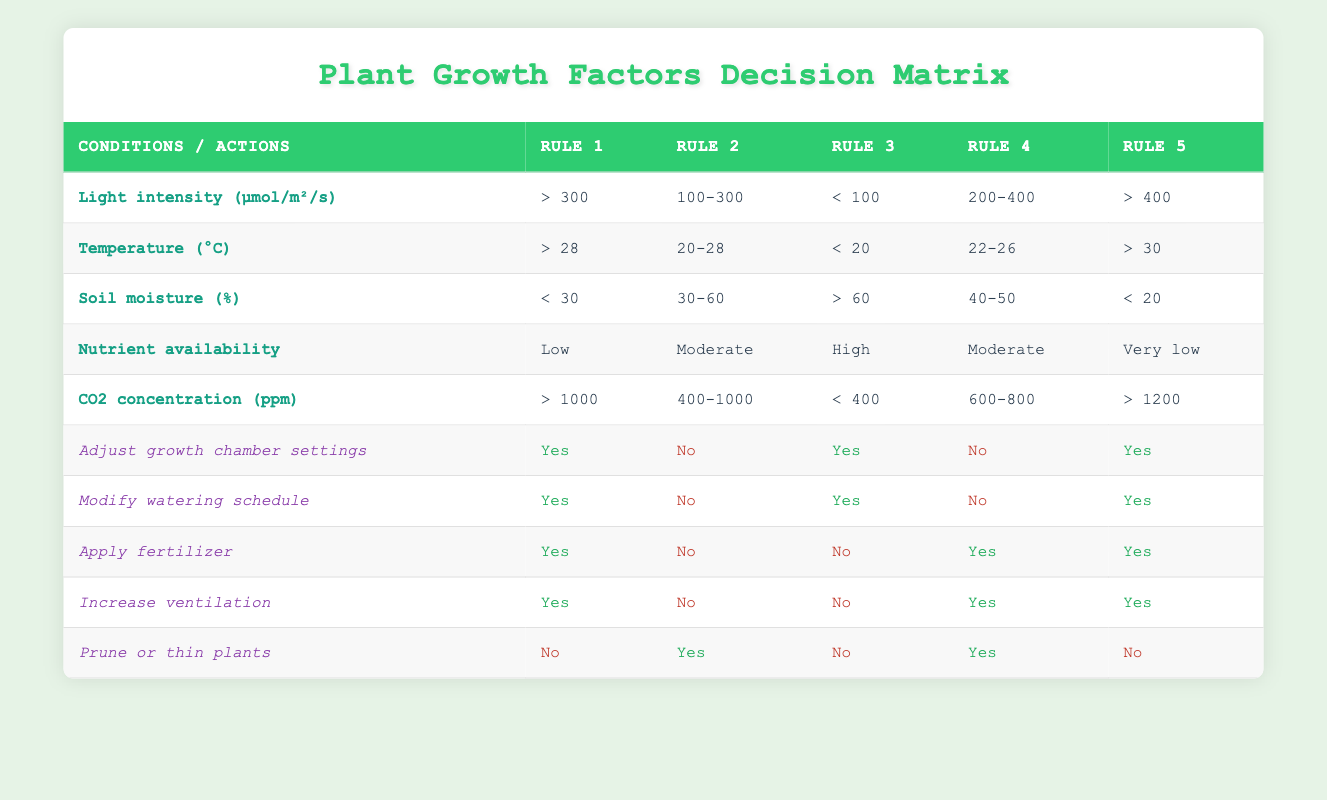What action should be taken if the soil moisture is less than 30%? According to Rule 1, if the soil moisture is less than 30%, the actions that need to be taken are to adjust growth chamber settings, modify watering schedule, apply fertilizer, and increase ventilation. Pruning or thinning plants is not recommended in this case.
Answer: Adjust growth chamber settings, modify watering schedule, apply fertilizer, increase ventilation What is the light intensity requirement for moderate nutrient availability? Looking at the rules, moderate nutrient availability appears in Rule 2 and Rule 4. The light intensity ranges for these rules are 100-300 μmol/m²/s and 200-400 μmol/m²/s respectively.
Answer: 100-300 μmol/m²/s or 200-400 μmol/m²/s Is it necessary to apply fertilizer when the temperature is between 22-26 °C? In Rule 4, with a temperature between 22-26 °C, applying fertilizer is necessary as indicated by "Yes". Therefore, it is necessary to apply fertilizer in this condition.
Answer: Yes What actions should not be taken if the CO2 concentration is greater than 1200 ppm? Referring to Rule 5, when CO2 concentration is greater than 1200 ppm, the actions not to be taken include pruning or thinning plants. The other actions (adjust growth chamber settings, modify watering schedule, apply fertilizer, increase ventilation) are recommended.
Answer: Prune or thin plants How many actions should be taken if the light intensity is between 200-400 μmol/m²/s? In Rule 4, with light intensity between 200-400 μmol/m²/s, the actions indicated are to apply fertilizer, increase ventilation, and prune or thin plants. That's a total of 3 actions.
Answer: 3 actions What is the average temperature range for cases requiring no changes in the growth chamber settings? The rules for no changes in growth chamber settings are Rule 2 and Rule 4. Rule 2 has a temperature range of 20-28 °C, and Rule 4 has a range of 22-26 °C. To find the average, we take the midpoint of these ranges: (20 + 28) / 2 = 24°C for Rule 2 and (22 + 26) / 2 = 24°C for Rule 4, hence the average is 24°C. The range was the same for the two rules.
Answer: 24°C 